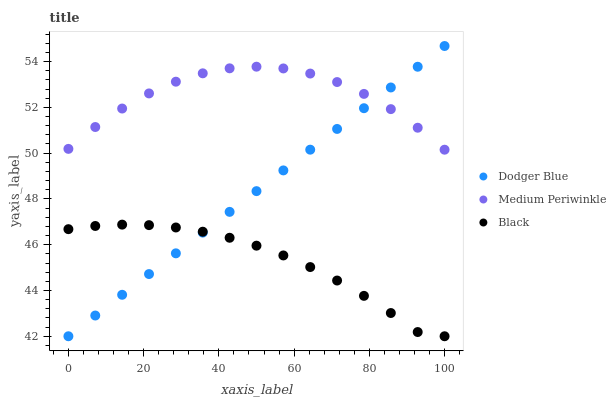Does Black have the minimum area under the curve?
Answer yes or no. Yes. Does Medium Periwinkle have the maximum area under the curve?
Answer yes or no. Yes. Does Dodger Blue have the minimum area under the curve?
Answer yes or no. No. Does Dodger Blue have the maximum area under the curve?
Answer yes or no. No. Is Dodger Blue the smoothest?
Answer yes or no. Yes. Is Medium Periwinkle the roughest?
Answer yes or no. Yes. Is Black the smoothest?
Answer yes or no. No. Is Black the roughest?
Answer yes or no. No. Does Dodger Blue have the lowest value?
Answer yes or no. Yes. Does Dodger Blue have the highest value?
Answer yes or no. Yes. Does Black have the highest value?
Answer yes or no. No. Is Black less than Medium Periwinkle?
Answer yes or no. Yes. Is Medium Periwinkle greater than Black?
Answer yes or no. Yes. Does Dodger Blue intersect Black?
Answer yes or no. Yes. Is Dodger Blue less than Black?
Answer yes or no. No. Is Dodger Blue greater than Black?
Answer yes or no. No. Does Black intersect Medium Periwinkle?
Answer yes or no. No. 